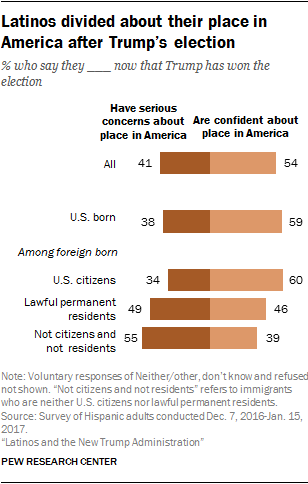Could we deduce the political climate's effect on the Latino community from this graphic? Certainly, the chart indicates that the political climate following Trump's election has had a differentiated impact on the Latino community, hinting at underlying complexities in their experiences and perceptions based on their birthplace and citizenship status. 